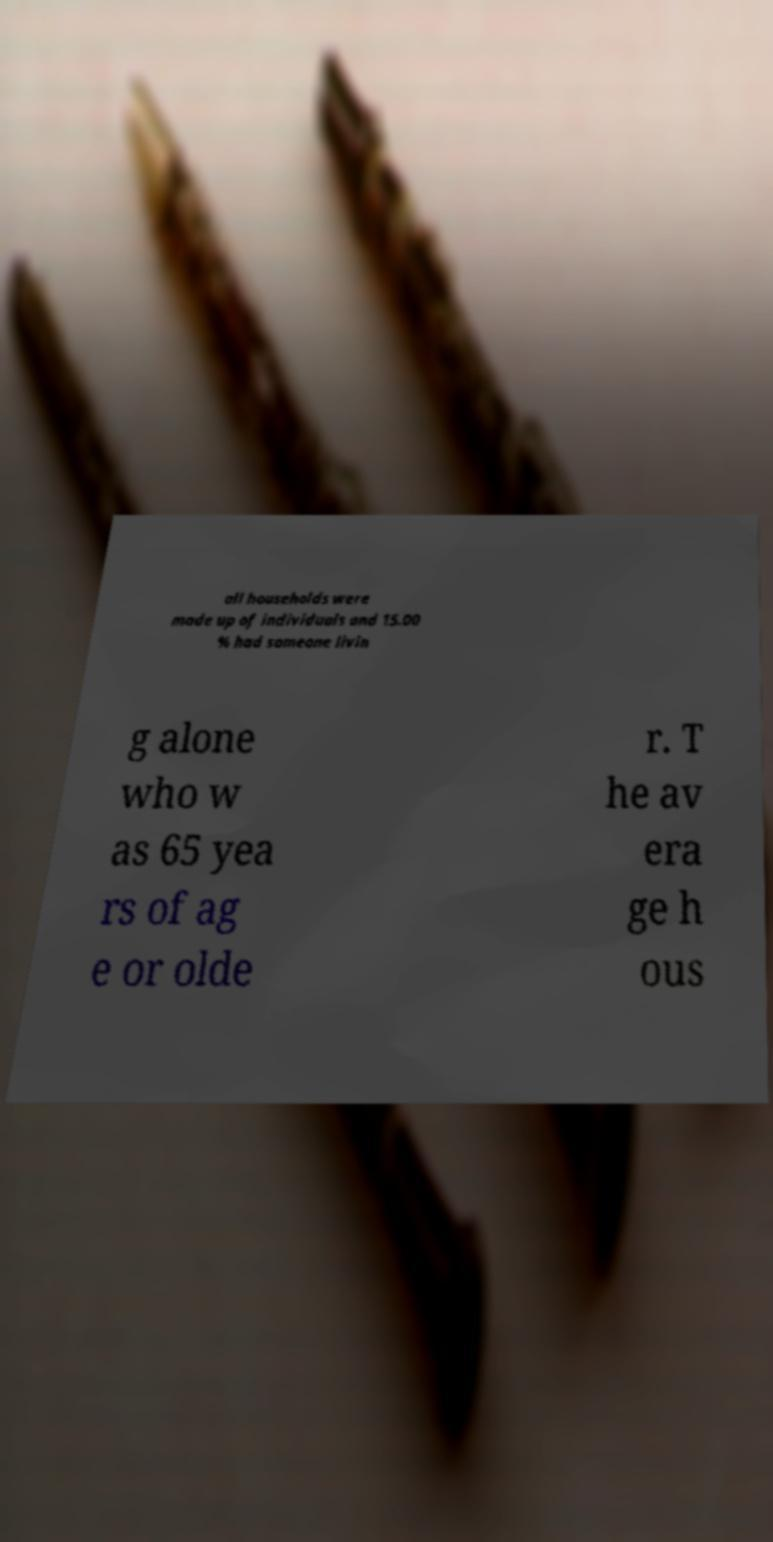Could you extract and type out the text from this image? all households were made up of individuals and 15.00 % had someone livin g alone who w as 65 yea rs of ag e or olde r. T he av era ge h ous 